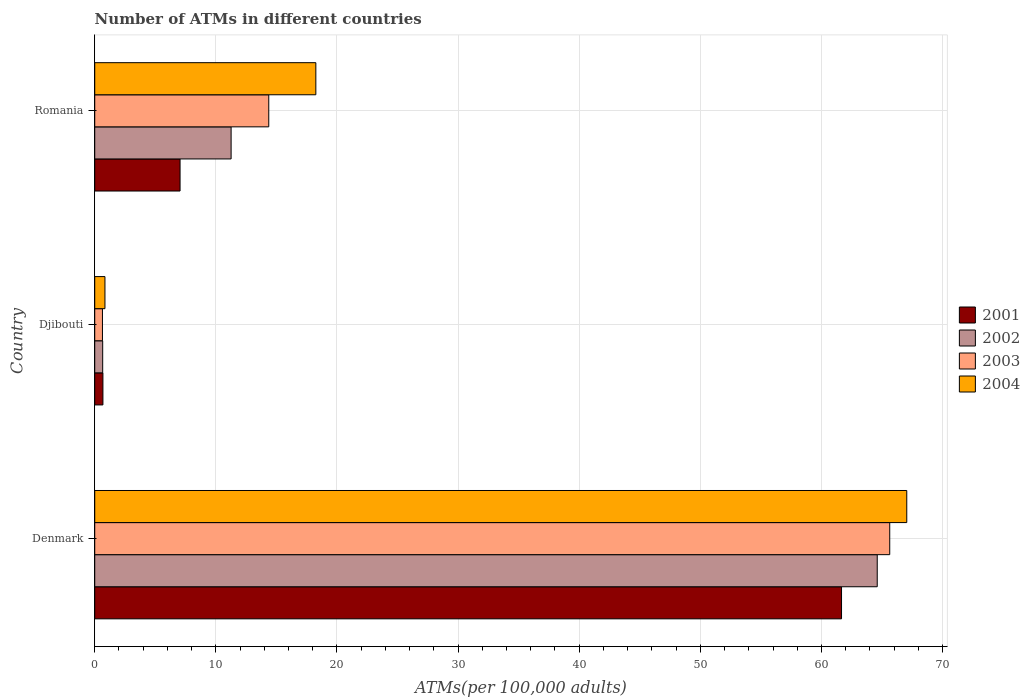Are the number of bars per tick equal to the number of legend labels?
Your response must be concise. Yes. Are the number of bars on each tick of the Y-axis equal?
Offer a very short reply. Yes. How many bars are there on the 2nd tick from the top?
Ensure brevity in your answer.  4. What is the label of the 3rd group of bars from the top?
Your answer should be very brief. Denmark. In how many cases, is the number of bars for a given country not equal to the number of legend labels?
Give a very brief answer. 0. What is the number of ATMs in 2004 in Djibouti?
Offer a terse response. 0.84. Across all countries, what is the maximum number of ATMs in 2001?
Your answer should be compact. 61.66. Across all countries, what is the minimum number of ATMs in 2003?
Offer a terse response. 0.64. In which country was the number of ATMs in 2004 minimum?
Give a very brief answer. Djibouti. What is the total number of ATMs in 2001 in the graph?
Give a very brief answer. 69.38. What is the difference between the number of ATMs in 2004 in Djibouti and that in Romania?
Make the answer very short. -17.41. What is the difference between the number of ATMs in 2003 in Denmark and the number of ATMs in 2004 in Djibouti?
Keep it short and to the point. 64.79. What is the average number of ATMs in 2001 per country?
Your answer should be very brief. 23.13. What is the difference between the number of ATMs in 2003 and number of ATMs in 2004 in Djibouti?
Ensure brevity in your answer.  -0.21. In how many countries, is the number of ATMs in 2001 greater than 68 ?
Offer a terse response. 0. What is the ratio of the number of ATMs in 2001 in Denmark to that in Romania?
Provide a succinct answer. 8.75. What is the difference between the highest and the second highest number of ATMs in 2004?
Offer a terse response. 48.79. What is the difference between the highest and the lowest number of ATMs in 2003?
Your answer should be compact. 65. Is the sum of the number of ATMs in 2003 in Denmark and Djibouti greater than the maximum number of ATMs in 2004 across all countries?
Provide a succinct answer. No. Is it the case that in every country, the sum of the number of ATMs in 2003 and number of ATMs in 2001 is greater than the sum of number of ATMs in 2004 and number of ATMs in 2002?
Give a very brief answer. No. Is it the case that in every country, the sum of the number of ATMs in 2003 and number of ATMs in 2001 is greater than the number of ATMs in 2002?
Provide a short and direct response. Yes. How many bars are there?
Your answer should be very brief. 12. Are all the bars in the graph horizontal?
Your response must be concise. Yes. Are the values on the major ticks of X-axis written in scientific E-notation?
Offer a terse response. No. Does the graph contain grids?
Provide a short and direct response. Yes. Where does the legend appear in the graph?
Your response must be concise. Center right. What is the title of the graph?
Your answer should be very brief. Number of ATMs in different countries. Does "1986" appear as one of the legend labels in the graph?
Make the answer very short. No. What is the label or title of the X-axis?
Offer a very short reply. ATMs(per 100,0 adults). What is the label or title of the Y-axis?
Make the answer very short. Country. What is the ATMs(per 100,000 adults) of 2001 in Denmark?
Provide a succinct answer. 61.66. What is the ATMs(per 100,000 adults) of 2002 in Denmark?
Offer a very short reply. 64.61. What is the ATMs(per 100,000 adults) in 2003 in Denmark?
Your response must be concise. 65.64. What is the ATMs(per 100,000 adults) of 2004 in Denmark?
Ensure brevity in your answer.  67.04. What is the ATMs(per 100,000 adults) in 2001 in Djibouti?
Provide a succinct answer. 0.68. What is the ATMs(per 100,000 adults) in 2002 in Djibouti?
Keep it short and to the point. 0.66. What is the ATMs(per 100,000 adults) of 2003 in Djibouti?
Your response must be concise. 0.64. What is the ATMs(per 100,000 adults) of 2004 in Djibouti?
Ensure brevity in your answer.  0.84. What is the ATMs(per 100,000 adults) in 2001 in Romania?
Offer a terse response. 7.04. What is the ATMs(per 100,000 adults) in 2002 in Romania?
Ensure brevity in your answer.  11.26. What is the ATMs(per 100,000 adults) in 2003 in Romania?
Provide a succinct answer. 14.37. What is the ATMs(per 100,000 adults) in 2004 in Romania?
Offer a terse response. 18.26. Across all countries, what is the maximum ATMs(per 100,000 adults) of 2001?
Give a very brief answer. 61.66. Across all countries, what is the maximum ATMs(per 100,000 adults) of 2002?
Give a very brief answer. 64.61. Across all countries, what is the maximum ATMs(per 100,000 adults) of 2003?
Your answer should be compact. 65.64. Across all countries, what is the maximum ATMs(per 100,000 adults) in 2004?
Your answer should be very brief. 67.04. Across all countries, what is the minimum ATMs(per 100,000 adults) in 2001?
Ensure brevity in your answer.  0.68. Across all countries, what is the minimum ATMs(per 100,000 adults) in 2002?
Offer a terse response. 0.66. Across all countries, what is the minimum ATMs(per 100,000 adults) of 2003?
Ensure brevity in your answer.  0.64. Across all countries, what is the minimum ATMs(per 100,000 adults) in 2004?
Offer a very short reply. 0.84. What is the total ATMs(per 100,000 adults) of 2001 in the graph?
Make the answer very short. 69.38. What is the total ATMs(per 100,000 adults) of 2002 in the graph?
Give a very brief answer. 76.52. What is the total ATMs(per 100,000 adults) in 2003 in the graph?
Give a very brief answer. 80.65. What is the total ATMs(per 100,000 adults) in 2004 in the graph?
Make the answer very short. 86.14. What is the difference between the ATMs(per 100,000 adults) in 2001 in Denmark and that in Djibouti?
Ensure brevity in your answer.  60.98. What is the difference between the ATMs(per 100,000 adults) of 2002 in Denmark and that in Djibouti?
Your answer should be very brief. 63.95. What is the difference between the ATMs(per 100,000 adults) of 2003 in Denmark and that in Djibouti?
Offer a terse response. 65. What is the difference between the ATMs(per 100,000 adults) in 2004 in Denmark and that in Djibouti?
Offer a very short reply. 66.2. What is the difference between the ATMs(per 100,000 adults) of 2001 in Denmark and that in Romania?
Ensure brevity in your answer.  54.61. What is the difference between the ATMs(per 100,000 adults) in 2002 in Denmark and that in Romania?
Your response must be concise. 53.35. What is the difference between the ATMs(per 100,000 adults) of 2003 in Denmark and that in Romania?
Provide a short and direct response. 51.27. What is the difference between the ATMs(per 100,000 adults) in 2004 in Denmark and that in Romania?
Provide a short and direct response. 48.79. What is the difference between the ATMs(per 100,000 adults) of 2001 in Djibouti and that in Romania?
Offer a terse response. -6.37. What is the difference between the ATMs(per 100,000 adults) in 2002 in Djibouti and that in Romania?
Provide a short and direct response. -10.6. What is the difference between the ATMs(per 100,000 adults) in 2003 in Djibouti and that in Romania?
Ensure brevity in your answer.  -13.73. What is the difference between the ATMs(per 100,000 adults) in 2004 in Djibouti and that in Romania?
Your response must be concise. -17.41. What is the difference between the ATMs(per 100,000 adults) in 2001 in Denmark and the ATMs(per 100,000 adults) in 2002 in Djibouti?
Provide a succinct answer. 61. What is the difference between the ATMs(per 100,000 adults) of 2001 in Denmark and the ATMs(per 100,000 adults) of 2003 in Djibouti?
Keep it short and to the point. 61.02. What is the difference between the ATMs(per 100,000 adults) of 2001 in Denmark and the ATMs(per 100,000 adults) of 2004 in Djibouti?
Provide a short and direct response. 60.81. What is the difference between the ATMs(per 100,000 adults) of 2002 in Denmark and the ATMs(per 100,000 adults) of 2003 in Djibouti?
Your answer should be compact. 63.97. What is the difference between the ATMs(per 100,000 adults) in 2002 in Denmark and the ATMs(per 100,000 adults) in 2004 in Djibouti?
Make the answer very short. 63.76. What is the difference between the ATMs(per 100,000 adults) of 2003 in Denmark and the ATMs(per 100,000 adults) of 2004 in Djibouti?
Offer a very short reply. 64.79. What is the difference between the ATMs(per 100,000 adults) in 2001 in Denmark and the ATMs(per 100,000 adults) in 2002 in Romania?
Provide a short and direct response. 50.4. What is the difference between the ATMs(per 100,000 adults) in 2001 in Denmark and the ATMs(per 100,000 adults) in 2003 in Romania?
Provide a short and direct response. 47.29. What is the difference between the ATMs(per 100,000 adults) in 2001 in Denmark and the ATMs(per 100,000 adults) in 2004 in Romania?
Your answer should be very brief. 43.4. What is the difference between the ATMs(per 100,000 adults) in 2002 in Denmark and the ATMs(per 100,000 adults) in 2003 in Romania?
Your answer should be compact. 50.24. What is the difference between the ATMs(per 100,000 adults) of 2002 in Denmark and the ATMs(per 100,000 adults) of 2004 in Romania?
Provide a succinct answer. 46.35. What is the difference between the ATMs(per 100,000 adults) of 2003 in Denmark and the ATMs(per 100,000 adults) of 2004 in Romania?
Offer a very short reply. 47.38. What is the difference between the ATMs(per 100,000 adults) in 2001 in Djibouti and the ATMs(per 100,000 adults) in 2002 in Romania?
Offer a terse response. -10.58. What is the difference between the ATMs(per 100,000 adults) in 2001 in Djibouti and the ATMs(per 100,000 adults) in 2003 in Romania?
Make the answer very short. -13.69. What is the difference between the ATMs(per 100,000 adults) in 2001 in Djibouti and the ATMs(per 100,000 adults) in 2004 in Romania?
Your answer should be very brief. -17.58. What is the difference between the ATMs(per 100,000 adults) in 2002 in Djibouti and the ATMs(per 100,000 adults) in 2003 in Romania?
Give a very brief answer. -13.71. What is the difference between the ATMs(per 100,000 adults) of 2002 in Djibouti and the ATMs(per 100,000 adults) of 2004 in Romania?
Keep it short and to the point. -17.6. What is the difference between the ATMs(per 100,000 adults) of 2003 in Djibouti and the ATMs(per 100,000 adults) of 2004 in Romania?
Offer a terse response. -17.62. What is the average ATMs(per 100,000 adults) of 2001 per country?
Your response must be concise. 23.13. What is the average ATMs(per 100,000 adults) in 2002 per country?
Give a very brief answer. 25.51. What is the average ATMs(per 100,000 adults) of 2003 per country?
Give a very brief answer. 26.88. What is the average ATMs(per 100,000 adults) of 2004 per country?
Offer a terse response. 28.71. What is the difference between the ATMs(per 100,000 adults) in 2001 and ATMs(per 100,000 adults) in 2002 in Denmark?
Ensure brevity in your answer.  -2.95. What is the difference between the ATMs(per 100,000 adults) in 2001 and ATMs(per 100,000 adults) in 2003 in Denmark?
Offer a terse response. -3.98. What is the difference between the ATMs(per 100,000 adults) of 2001 and ATMs(per 100,000 adults) of 2004 in Denmark?
Provide a short and direct response. -5.39. What is the difference between the ATMs(per 100,000 adults) in 2002 and ATMs(per 100,000 adults) in 2003 in Denmark?
Provide a succinct answer. -1.03. What is the difference between the ATMs(per 100,000 adults) in 2002 and ATMs(per 100,000 adults) in 2004 in Denmark?
Provide a succinct answer. -2.44. What is the difference between the ATMs(per 100,000 adults) of 2003 and ATMs(per 100,000 adults) of 2004 in Denmark?
Offer a terse response. -1.41. What is the difference between the ATMs(per 100,000 adults) in 2001 and ATMs(per 100,000 adults) in 2002 in Djibouti?
Provide a succinct answer. 0.02. What is the difference between the ATMs(per 100,000 adults) in 2001 and ATMs(per 100,000 adults) in 2003 in Djibouti?
Make the answer very short. 0.04. What is the difference between the ATMs(per 100,000 adults) in 2001 and ATMs(per 100,000 adults) in 2004 in Djibouti?
Your response must be concise. -0.17. What is the difference between the ATMs(per 100,000 adults) of 2002 and ATMs(per 100,000 adults) of 2003 in Djibouti?
Offer a very short reply. 0.02. What is the difference between the ATMs(per 100,000 adults) of 2002 and ATMs(per 100,000 adults) of 2004 in Djibouti?
Provide a succinct answer. -0.19. What is the difference between the ATMs(per 100,000 adults) in 2003 and ATMs(per 100,000 adults) in 2004 in Djibouti?
Offer a terse response. -0.21. What is the difference between the ATMs(per 100,000 adults) in 2001 and ATMs(per 100,000 adults) in 2002 in Romania?
Provide a short and direct response. -4.21. What is the difference between the ATMs(per 100,000 adults) of 2001 and ATMs(per 100,000 adults) of 2003 in Romania?
Provide a short and direct response. -7.32. What is the difference between the ATMs(per 100,000 adults) of 2001 and ATMs(per 100,000 adults) of 2004 in Romania?
Ensure brevity in your answer.  -11.21. What is the difference between the ATMs(per 100,000 adults) of 2002 and ATMs(per 100,000 adults) of 2003 in Romania?
Your response must be concise. -3.11. What is the difference between the ATMs(per 100,000 adults) in 2002 and ATMs(per 100,000 adults) in 2004 in Romania?
Make the answer very short. -7. What is the difference between the ATMs(per 100,000 adults) of 2003 and ATMs(per 100,000 adults) of 2004 in Romania?
Make the answer very short. -3.89. What is the ratio of the ATMs(per 100,000 adults) of 2001 in Denmark to that in Djibouti?
Your answer should be compact. 91.18. What is the ratio of the ATMs(per 100,000 adults) in 2002 in Denmark to that in Djibouti?
Offer a terse response. 98.45. What is the ratio of the ATMs(per 100,000 adults) of 2003 in Denmark to that in Djibouti?
Ensure brevity in your answer.  102.88. What is the ratio of the ATMs(per 100,000 adults) in 2004 in Denmark to that in Djibouti?
Offer a very short reply. 79.46. What is the ratio of the ATMs(per 100,000 adults) of 2001 in Denmark to that in Romania?
Your answer should be compact. 8.75. What is the ratio of the ATMs(per 100,000 adults) in 2002 in Denmark to that in Romania?
Give a very brief answer. 5.74. What is the ratio of the ATMs(per 100,000 adults) in 2003 in Denmark to that in Romania?
Offer a very short reply. 4.57. What is the ratio of the ATMs(per 100,000 adults) in 2004 in Denmark to that in Romania?
Offer a terse response. 3.67. What is the ratio of the ATMs(per 100,000 adults) in 2001 in Djibouti to that in Romania?
Your answer should be compact. 0.1. What is the ratio of the ATMs(per 100,000 adults) of 2002 in Djibouti to that in Romania?
Keep it short and to the point. 0.06. What is the ratio of the ATMs(per 100,000 adults) in 2003 in Djibouti to that in Romania?
Your answer should be compact. 0.04. What is the ratio of the ATMs(per 100,000 adults) in 2004 in Djibouti to that in Romania?
Provide a short and direct response. 0.05. What is the difference between the highest and the second highest ATMs(per 100,000 adults) in 2001?
Provide a succinct answer. 54.61. What is the difference between the highest and the second highest ATMs(per 100,000 adults) of 2002?
Give a very brief answer. 53.35. What is the difference between the highest and the second highest ATMs(per 100,000 adults) in 2003?
Give a very brief answer. 51.27. What is the difference between the highest and the second highest ATMs(per 100,000 adults) in 2004?
Give a very brief answer. 48.79. What is the difference between the highest and the lowest ATMs(per 100,000 adults) of 2001?
Your answer should be very brief. 60.98. What is the difference between the highest and the lowest ATMs(per 100,000 adults) of 2002?
Provide a short and direct response. 63.95. What is the difference between the highest and the lowest ATMs(per 100,000 adults) in 2003?
Your answer should be compact. 65. What is the difference between the highest and the lowest ATMs(per 100,000 adults) of 2004?
Your answer should be compact. 66.2. 